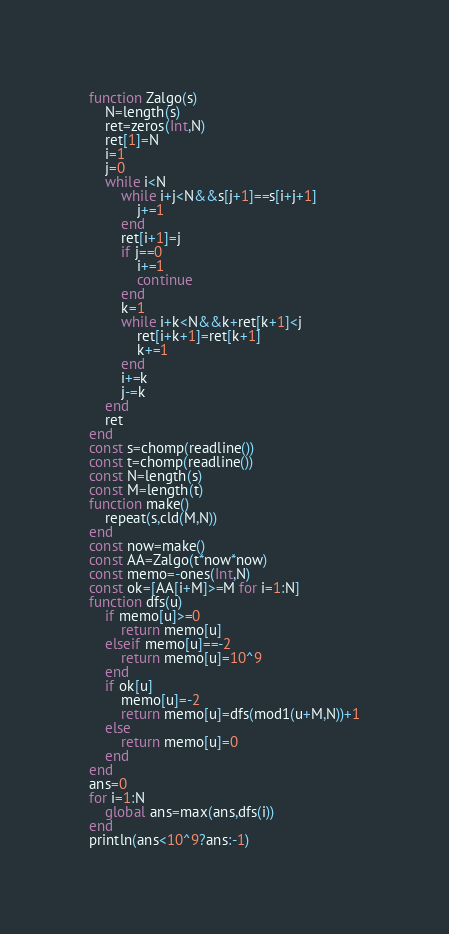Convert code to text. <code><loc_0><loc_0><loc_500><loc_500><_Julia_>function Zalgo(s)
	N=length(s)
	ret=zeros(Int,N)
	ret[1]=N
	i=1
	j=0
	while i<N
		while i+j<N&&s[j+1]==s[i+j+1]
			j+=1
		end
		ret[i+1]=j
		if j==0
			i+=1
			continue
		end
		k=1
		while i+k<N&&k+ret[k+1]<j
			ret[i+k+1]=ret[k+1]
			k+=1
		end
		i+=k
		j-=k
	end
	ret
end
const s=chomp(readline())
const t=chomp(readline())
const N=length(s)
const M=length(t)
function make()
	repeat(s,cld(M,N))
end
const now=make()
const AA=Zalgo(t*now*now)
const memo=-ones(Int,N)
const ok=[AA[i+M]>=M for i=1:N]
function dfs(u)
	if memo[u]>=0
		return memo[u]
	elseif memo[u]==-2
		return memo[u]=10^9
	end
	if ok[u]
		memo[u]=-2
		return memo[u]=dfs(mod1(u+M,N))+1
	else
		return memo[u]=0
	end
end
ans=0
for i=1:N
	global ans=max(ans,dfs(i))
end
println(ans<10^9?ans:-1)
</code> 